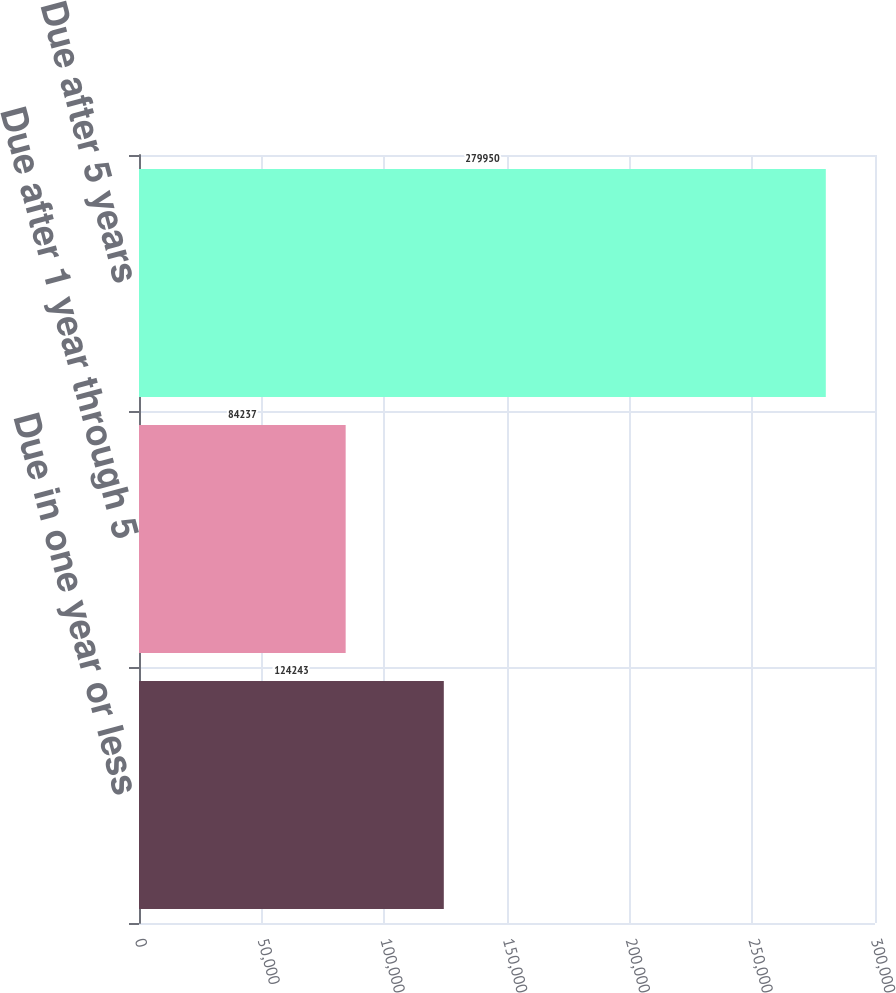Convert chart to OTSL. <chart><loc_0><loc_0><loc_500><loc_500><bar_chart><fcel>Due in one year or less<fcel>Due after 1 year through 5<fcel>Due after 5 years<nl><fcel>124243<fcel>84237<fcel>279950<nl></chart> 